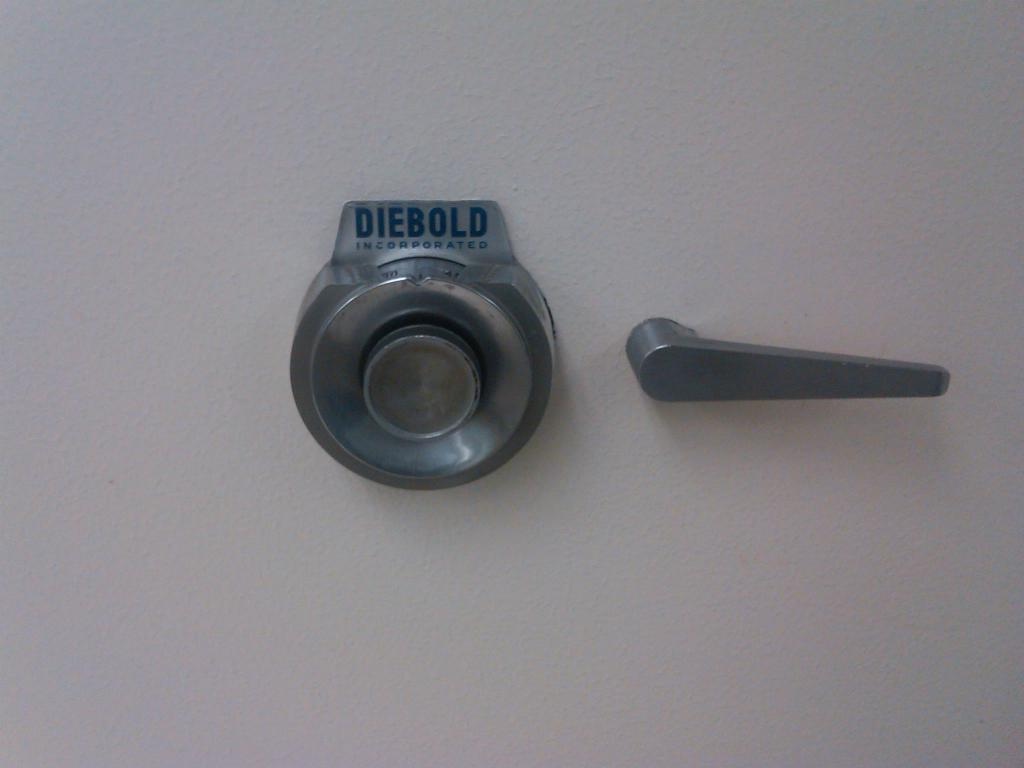What type of objects are on the wall in the image? There are two metal objects on the wall. What can be found on the metal objects? There is text on the metal objects. Can you see any goldfish swimming around the metal objects in the image? There are no goldfish present in the image; it features two metal objects with text on them. Is there a goose standing next to the metal objects in the image? There is no goose present in the image; it only features two metal objects with text on them. 